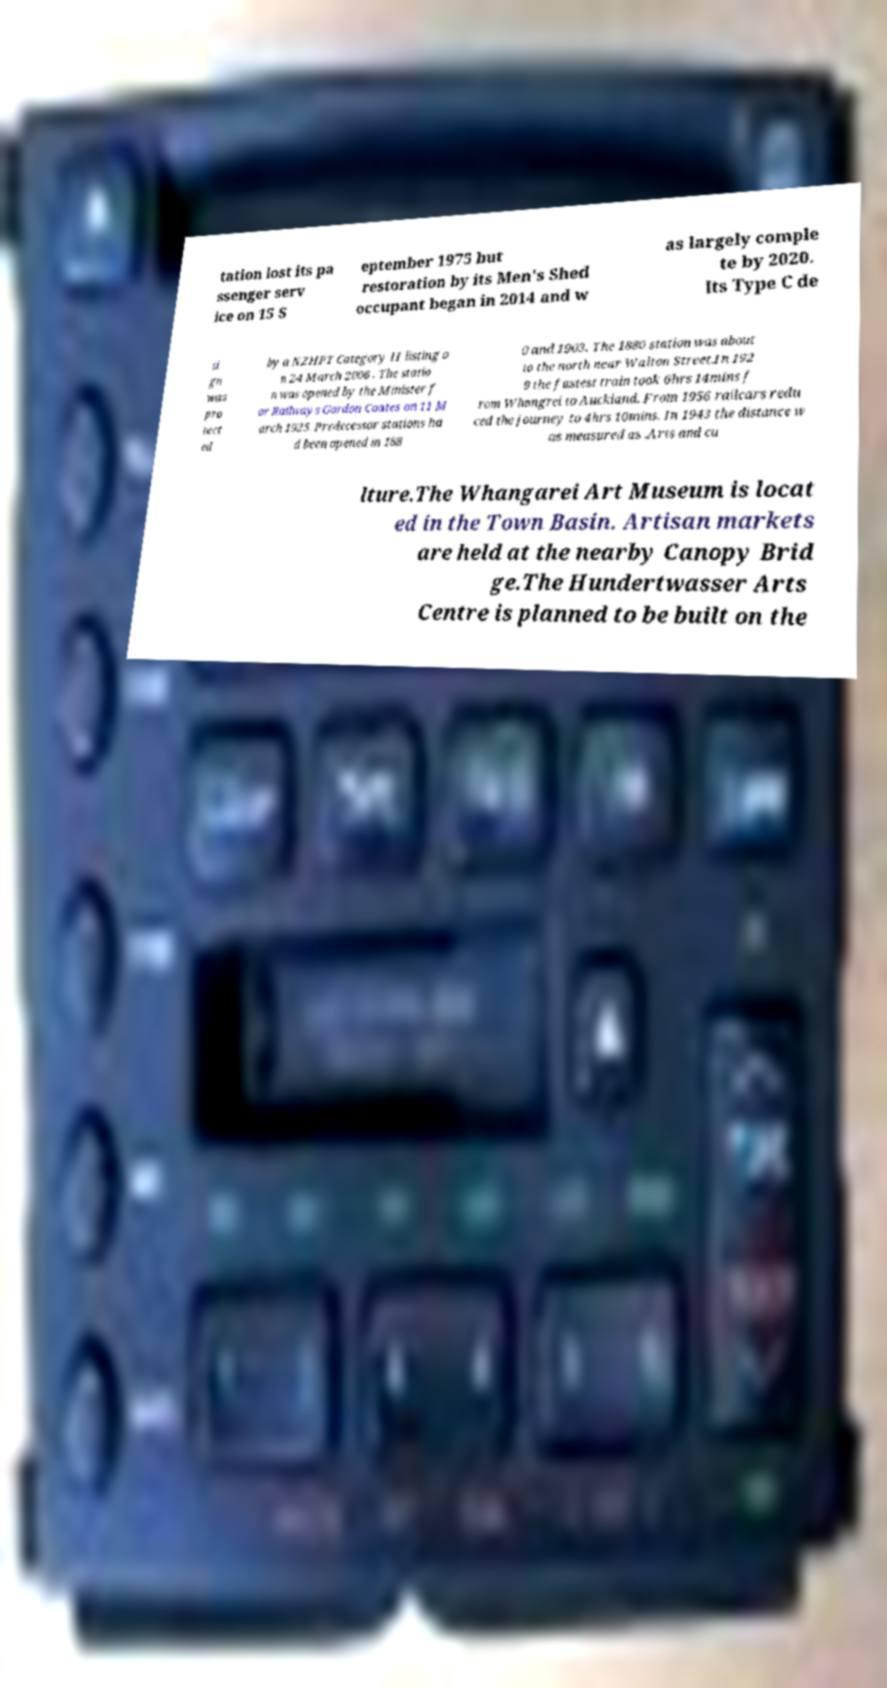Could you assist in decoding the text presented in this image and type it out clearly? tation lost its pa ssenger serv ice on 15 S eptember 1975 but restoration by its Men's Shed occupant began in 2014 and w as largely comple te by 2020. Its Type C de si gn was pro tect ed by a NZHPT Category II listing o n 24 March 2006 . The statio n was opened by the Minister f or Railways Gordon Coates on 11 M arch 1925. Predecessor stations ha d been opened in 188 0 and 1903. The 1880 station was about to the north near Walton Street.In 192 9 the fastest train took 6hrs 14mins f rom Whangrei to Auckland. From 1956 railcars redu ced the journey to 4hrs 10mins. In 1943 the distance w as measured as .Arts and cu lture.The Whangarei Art Museum is locat ed in the Town Basin. Artisan markets are held at the nearby Canopy Brid ge.The Hundertwasser Arts Centre is planned to be built on the 